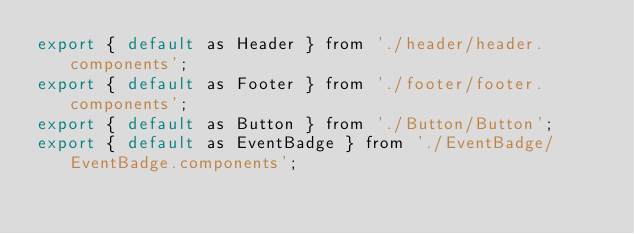<code> <loc_0><loc_0><loc_500><loc_500><_JavaScript_>export { default as Header } from './header/header.components';
export { default as Footer } from './footer/footer.components';
export { default as Button } from './Button/Button';
export { default as EventBadge } from './EventBadge/EventBadge.components';</code> 